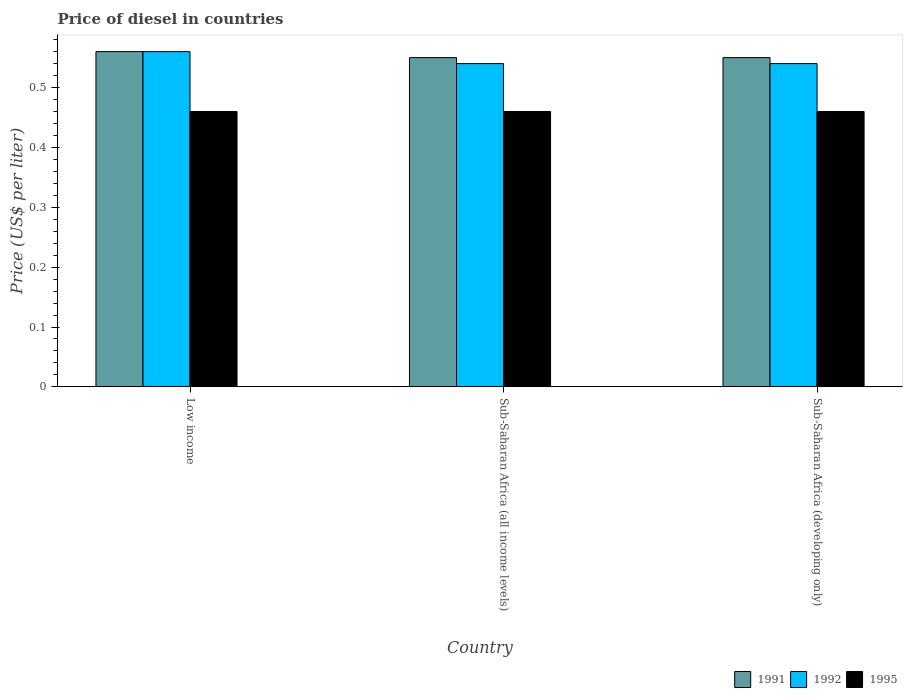How many different coloured bars are there?
Offer a very short reply. 3. How many bars are there on the 1st tick from the left?
Ensure brevity in your answer.  3. How many bars are there on the 1st tick from the right?
Your answer should be compact. 3. What is the label of the 3rd group of bars from the left?
Your answer should be very brief. Sub-Saharan Africa (developing only). What is the price of diesel in 1995 in Sub-Saharan Africa (developing only)?
Keep it short and to the point. 0.46. Across all countries, what is the maximum price of diesel in 1992?
Your answer should be compact. 0.56. Across all countries, what is the minimum price of diesel in 1995?
Your response must be concise. 0.46. In which country was the price of diesel in 1991 maximum?
Offer a very short reply. Low income. In which country was the price of diesel in 1991 minimum?
Offer a terse response. Sub-Saharan Africa (all income levels). What is the total price of diesel in 1991 in the graph?
Provide a succinct answer. 1.66. What is the difference between the price of diesel in 1995 in Low income and the price of diesel in 1992 in Sub-Saharan Africa (developing only)?
Ensure brevity in your answer.  -0.08. What is the average price of diesel in 1992 per country?
Give a very brief answer. 0.55. What is the difference between the price of diesel of/in 1992 and price of diesel of/in 1991 in Sub-Saharan Africa (all income levels)?
Provide a short and direct response. -0.01. What is the ratio of the price of diesel in 1991 in Low income to that in Sub-Saharan Africa (all income levels)?
Ensure brevity in your answer.  1.02. Is the price of diesel in 1995 in Low income less than that in Sub-Saharan Africa (developing only)?
Your answer should be very brief. No. What is the difference between the highest and the second highest price of diesel in 1992?
Offer a terse response. 0.02. What is the difference between the highest and the lowest price of diesel in 1991?
Offer a very short reply. 0.01. What does the 3rd bar from the right in Sub-Saharan Africa (developing only) represents?
Make the answer very short. 1991. Is it the case that in every country, the sum of the price of diesel in 1992 and price of diesel in 1991 is greater than the price of diesel in 1995?
Offer a very short reply. Yes. How many bars are there?
Your answer should be compact. 9. Are all the bars in the graph horizontal?
Your answer should be compact. No. Does the graph contain grids?
Ensure brevity in your answer.  No. What is the title of the graph?
Offer a terse response. Price of diesel in countries. What is the label or title of the X-axis?
Provide a succinct answer. Country. What is the label or title of the Y-axis?
Your answer should be compact. Price (US$ per liter). What is the Price (US$ per liter) of 1991 in Low income?
Give a very brief answer. 0.56. What is the Price (US$ per liter) in 1992 in Low income?
Offer a very short reply. 0.56. What is the Price (US$ per liter) of 1995 in Low income?
Keep it short and to the point. 0.46. What is the Price (US$ per liter) of 1991 in Sub-Saharan Africa (all income levels)?
Your answer should be compact. 0.55. What is the Price (US$ per liter) of 1992 in Sub-Saharan Africa (all income levels)?
Provide a succinct answer. 0.54. What is the Price (US$ per liter) in 1995 in Sub-Saharan Africa (all income levels)?
Provide a succinct answer. 0.46. What is the Price (US$ per liter) in 1991 in Sub-Saharan Africa (developing only)?
Make the answer very short. 0.55. What is the Price (US$ per liter) in 1992 in Sub-Saharan Africa (developing only)?
Keep it short and to the point. 0.54. What is the Price (US$ per liter) of 1995 in Sub-Saharan Africa (developing only)?
Make the answer very short. 0.46. Across all countries, what is the maximum Price (US$ per liter) in 1991?
Ensure brevity in your answer.  0.56. Across all countries, what is the maximum Price (US$ per liter) of 1992?
Your answer should be compact. 0.56. Across all countries, what is the maximum Price (US$ per liter) in 1995?
Provide a short and direct response. 0.46. Across all countries, what is the minimum Price (US$ per liter) of 1991?
Your answer should be compact. 0.55. Across all countries, what is the minimum Price (US$ per liter) of 1992?
Make the answer very short. 0.54. Across all countries, what is the minimum Price (US$ per liter) in 1995?
Your answer should be compact. 0.46. What is the total Price (US$ per liter) in 1991 in the graph?
Provide a short and direct response. 1.66. What is the total Price (US$ per liter) in 1992 in the graph?
Offer a very short reply. 1.64. What is the total Price (US$ per liter) of 1995 in the graph?
Your answer should be very brief. 1.38. What is the difference between the Price (US$ per liter) in 1991 in Low income and that in Sub-Saharan Africa (all income levels)?
Ensure brevity in your answer.  0.01. What is the difference between the Price (US$ per liter) of 1992 in Low income and that in Sub-Saharan Africa (developing only)?
Keep it short and to the point. 0.02. What is the difference between the Price (US$ per liter) in 1991 in Low income and the Price (US$ per liter) in 1995 in Sub-Saharan Africa (all income levels)?
Your answer should be compact. 0.1. What is the difference between the Price (US$ per liter) in 1991 in Low income and the Price (US$ per liter) in 1992 in Sub-Saharan Africa (developing only)?
Offer a very short reply. 0.02. What is the difference between the Price (US$ per liter) of 1991 in Sub-Saharan Africa (all income levels) and the Price (US$ per liter) of 1995 in Sub-Saharan Africa (developing only)?
Provide a short and direct response. 0.09. What is the average Price (US$ per liter) of 1991 per country?
Your answer should be compact. 0.55. What is the average Price (US$ per liter) of 1992 per country?
Provide a short and direct response. 0.55. What is the average Price (US$ per liter) of 1995 per country?
Provide a short and direct response. 0.46. What is the difference between the Price (US$ per liter) of 1991 and Price (US$ per liter) of 1995 in Low income?
Ensure brevity in your answer.  0.1. What is the difference between the Price (US$ per liter) in 1992 and Price (US$ per liter) in 1995 in Low income?
Keep it short and to the point. 0.1. What is the difference between the Price (US$ per liter) of 1991 and Price (US$ per liter) of 1995 in Sub-Saharan Africa (all income levels)?
Ensure brevity in your answer.  0.09. What is the difference between the Price (US$ per liter) in 1991 and Price (US$ per liter) in 1995 in Sub-Saharan Africa (developing only)?
Ensure brevity in your answer.  0.09. What is the ratio of the Price (US$ per liter) of 1991 in Low income to that in Sub-Saharan Africa (all income levels)?
Keep it short and to the point. 1.02. What is the ratio of the Price (US$ per liter) of 1995 in Low income to that in Sub-Saharan Africa (all income levels)?
Offer a terse response. 1. What is the ratio of the Price (US$ per liter) of 1991 in Low income to that in Sub-Saharan Africa (developing only)?
Ensure brevity in your answer.  1.02. What is the ratio of the Price (US$ per liter) in 1992 in Low income to that in Sub-Saharan Africa (developing only)?
Your answer should be very brief. 1.04. What is the ratio of the Price (US$ per liter) of 1995 in Sub-Saharan Africa (all income levels) to that in Sub-Saharan Africa (developing only)?
Your answer should be very brief. 1. What is the difference between the highest and the second highest Price (US$ per liter) of 1992?
Provide a short and direct response. 0.02. What is the difference between the highest and the lowest Price (US$ per liter) of 1991?
Provide a succinct answer. 0.01. What is the difference between the highest and the lowest Price (US$ per liter) of 1992?
Provide a short and direct response. 0.02. What is the difference between the highest and the lowest Price (US$ per liter) of 1995?
Make the answer very short. 0. 